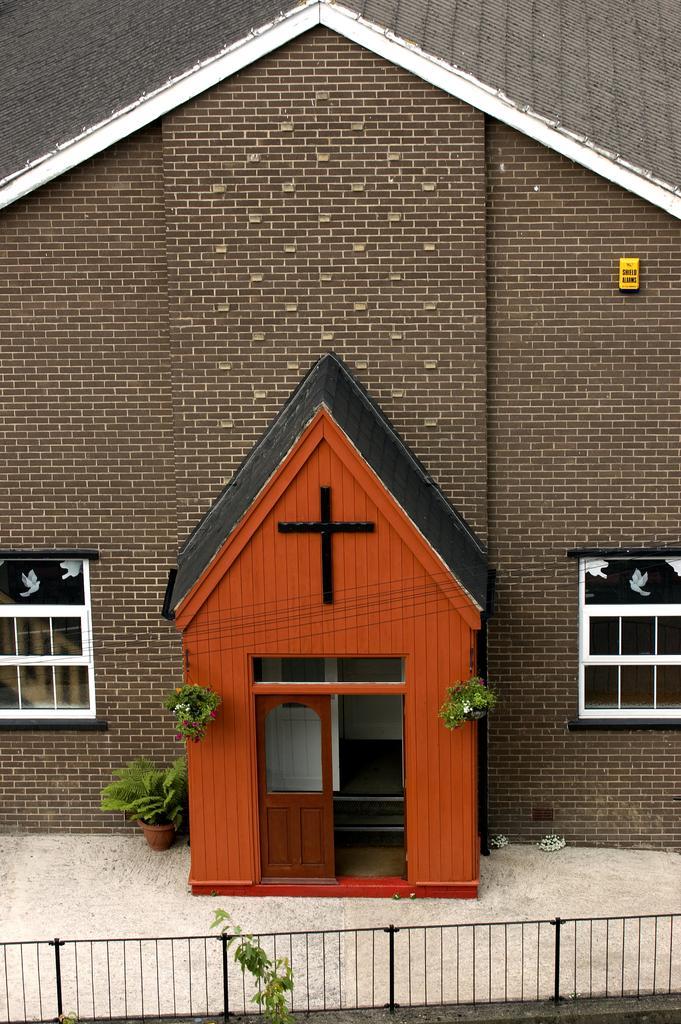Please provide a concise description of this image. In this picture we can see a house, windows, roof top, door. We can see the plants, pot and we can see yellow object on the wall. At the bottom portion of the picture we can see the railing. 